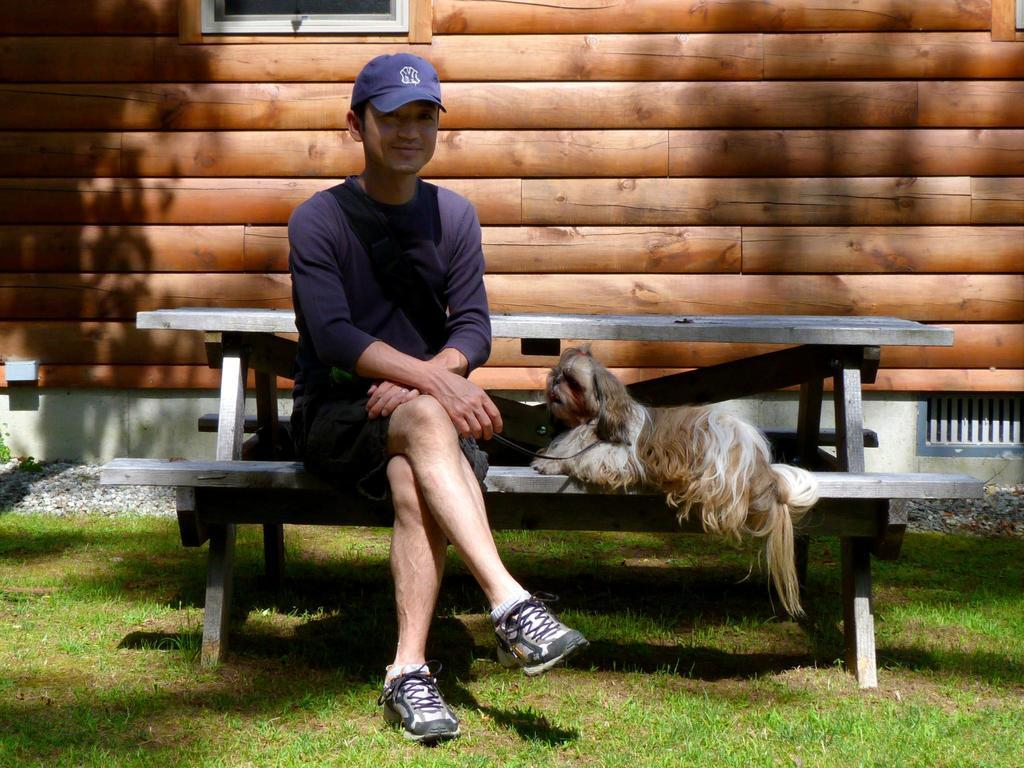What is the person in the image doing? There is a person sitting on a bench in the image. What type of animal is present in the image? There is a dog in the image. What can be seen in the background of the image? There is a window and a wall in the background of the image. What type of ground surface is visible in the image? There is grass in the image. What type of prose is being read by the person sitting on the bench in the image? There is no indication in the image that the person is reading any prose, as the focus is on the person sitting on the bench and the presence of a dog. 